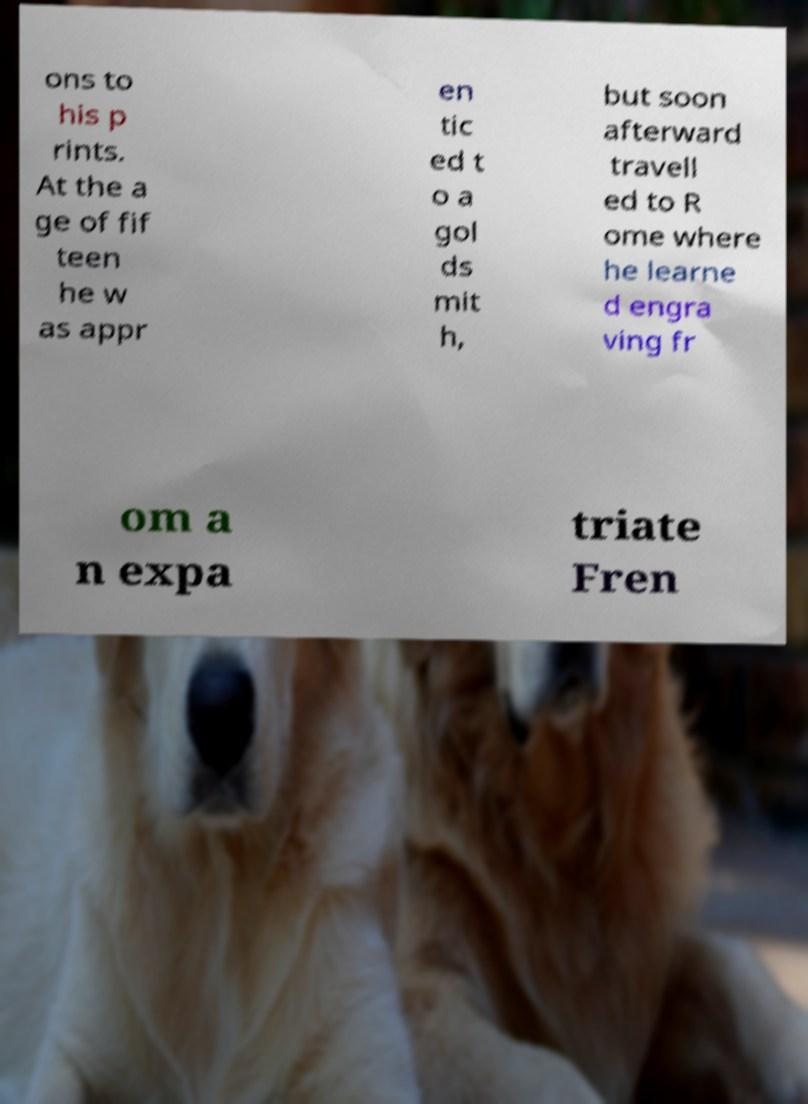Can you read and provide the text displayed in the image?This photo seems to have some interesting text. Can you extract and type it out for me? ons to his p rints. At the a ge of fif teen he w as appr en tic ed t o a gol ds mit h, but soon afterward travell ed to R ome where he learne d engra ving fr om a n expa triate Fren 